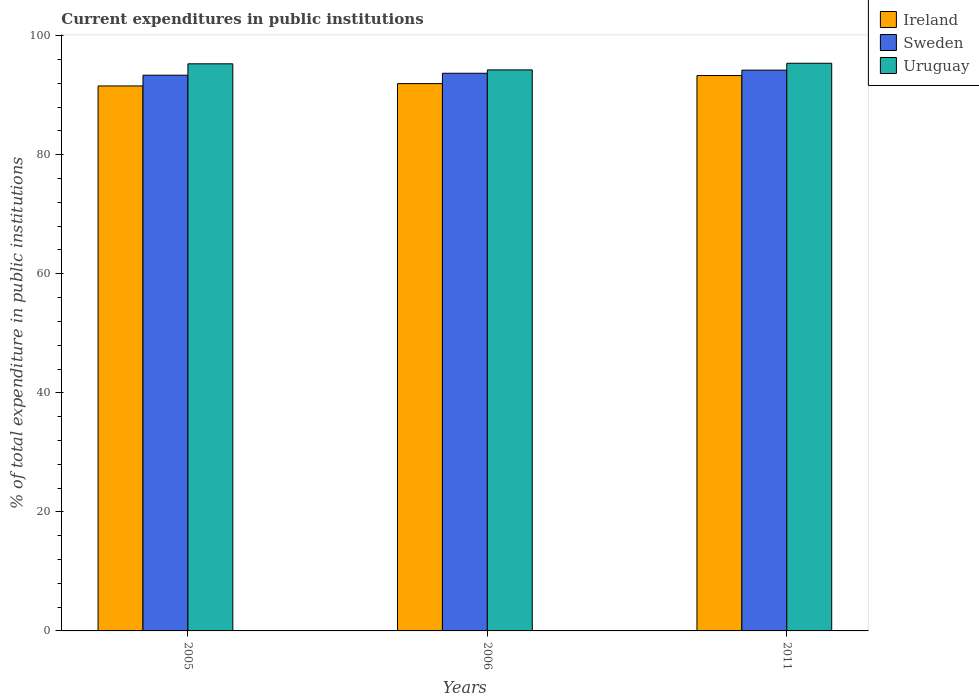How many different coloured bars are there?
Your answer should be compact. 3. How many groups of bars are there?
Make the answer very short. 3. How many bars are there on the 2nd tick from the left?
Make the answer very short. 3. How many bars are there on the 2nd tick from the right?
Offer a terse response. 3. In how many cases, is the number of bars for a given year not equal to the number of legend labels?
Your answer should be very brief. 0. What is the current expenditures in public institutions in Ireland in 2006?
Offer a terse response. 91.95. Across all years, what is the maximum current expenditures in public institutions in Sweden?
Your answer should be compact. 94.22. Across all years, what is the minimum current expenditures in public institutions in Uruguay?
Keep it short and to the point. 94.26. What is the total current expenditures in public institutions in Ireland in the graph?
Provide a short and direct response. 276.82. What is the difference between the current expenditures in public institutions in Uruguay in 2006 and that in 2011?
Offer a very short reply. -1.12. What is the difference between the current expenditures in public institutions in Sweden in 2011 and the current expenditures in public institutions in Uruguay in 2006?
Your response must be concise. -0.04. What is the average current expenditures in public institutions in Ireland per year?
Your answer should be very brief. 92.27. In the year 2011, what is the difference between the current expenditures in public institutions in Sweden and current expenditures in public institutions in Uruguay?
Keep it short and to the point. -1.15. What is the ratio of the current expenditures in public institutions in Uruguay in 2005 to that in 2006?
Your response must be concise. 1.01. What is the difference between the highest and the second highest current expenditures in public institutions in Sweden?
Make the answer very short. 0.52. What is the difference between the highest and the lowest current expenditures in public institutions in Ireland?
Keep it short and to the point. 1.75. What does the 1st bar from the left in 2005 represents?
Your answer should be compact. Ireland. What does the 2nd bar from the right in 2011 represents?
Offer a very short reply. Sweden. How many bars are there?
Offer a terse response. 9. How many years are there in the graph?
Keep it short and to the point. 3. Does the graph contain grids?
Your answer should be very brief. No. Where does the legend appear in the graph?
Offer a terse response. Top right. How many legend labels are there?
Make the answer very short. 3. What is the title of the graph?
Provide a short and direct response. Current expenditures in public institutions. Does "Togo" appear as one of the legend labels in the graph?
Make the answer very short. No. What is the label or title of the X-axis?
Ensure brevity in your answer.  Years. What is the label or title of the Y-axis?
Your response must be concise. % of total expenditure in public institutions. What is the % of total expenditure in public institutions in Ireland in 2005?
Give a very brief answer. 91.56. What is the % of total expenditure in public institutions in Sweden in 2005?
Your response must be concise. 93.37. What is the % of total expenditure in public institutions in Uruguay in 2005?
Your answer should be compact. 95.28. What is the % of total expenditure in public institutions of Ireland in 2006?
Your answer should be compact. 91.95. What is the % of total expenditure in public institutions in Sweden in 2006?
Provide a succinct answer. 93.69. What is the % of total expenditure in public institutions of Uruguay in 2006?
Offer a very short reply. 94.26. What is the % of total expenditure in public institutions of Ireland in 2011?
Make the answer very short. 93.31. What is the % of total expenditure in public institutions of Sweden in 2011?
Provide a succinct answer. 94.22. What is the % of total expenditure in public institutions of Uruguay in 2011?
Your answer should be very brief. 95.37. Across all years, what is the maximum % of total expenditure in public institutions in Ireland?
Provide a short and direct response. 93.31. Across all years, what is the maximum % of total expenditure in public institutions of Sweden?
Keep it short and to the point. 94.22. Across all years, what is the maximum % of total expenditure in public institutions in Uruguay?
Offer a very short reply. 95.37. Across all years, what is the minimum % of total expenditure in public institutions of Ireland?
Offer a terse response. 91.56. Across all years, what is the minimum % of total expenditure in public institutions in Sweden?
Offer a terse response. 93.37. Across all years, what is the minimum % of total expenditure in public institutions in Uruguay?
Your answer should be compact. 94.26. What is the total % of total expenditure in public institutions of Ireland in the graph?
Ensure brevity in your answer.  276.82. What is the total % of total expenditure in public institutions in Sweden in the graph?
Your answer should be very brief. 281.28. What is the total % of total expenditure in public institutions of Uruguay in the graph?
Your response must be concise. 284.91. What is the difference between the % of total expenditure in public institutions of Ireland in 2005 and that in 2006?
Provide a short and direct response. -0.39. What is the difference between the % of total expenditure in public institutions in Sweden in 2005 and that in 2006?
Ensure brevity in your answer.  -0.33. What is the difference between the % of total expenditure in public institutions of Uruguay in 2005 and that in 2006?
Offer a terse response. 1.02. What is the difference between the % of total expenditure in public institutions of Ireland in 2005 and that in 2011?
Keep it short and to the point. -1.75. What is the difference between the % of total expenditure in public institutions of Sweden in 2005 and that in 2011?
Offer a very short reply. -0.85. What is the difference between the % of total expenditure in public institutions in Uruguay in 2005 and that in 2011?
Make the answer very short. -0.1. What is the difference between the % of total expenditure in public institutions of Ireland in 2006 and that in 2011?
Make the answer very short. -1.36. What is the difference between the % of total expenditure in public institutions of Sweden in 2006 and that in 2011?
Offer a very short reply. -0.52. What is the difference between the % of total expenditure in public institutions of Uruguay in 2006 and that in 2011?
Provide a short and direct response. -1.12. What is the difference between the % of total expenditure in public institutions of Ireland in 2005 and the % of total expenditure in public institutions of Sweden in 2006?
Keep it short and to the point. -2.13. What is the difference between the % of total expenditure in public institutions in Ireland in 2005 and the % of total expenditure in public institutions in Uruguay in 2006?
Make the answer very short. -2.7. What is the difference between the % of total expenditure in public institutions of Sweden in 2005 and the % of total expenditure in public institutions of Uruguay in 2006?
Make the answer very short. -0.89. What is the difference between the % of total expenditure in public institutions in Ireland in 2005 and the % of total expenditure in public institutions in Sweden in 2011?
Your answer should be compact. -2.66. What is the difference between the % of total expenditure in public institutions of Ireland in 2005 and the % of total expenditure in public institutions of Uruguay in 2011?
Keep it short and to the point. -3.81. What is the difference between the % of total expenditure in public institutions in Sweden in 2005 and the % of total expenditure in public institutions in Uruguay in 2011?
Offer a terse response. -2.01. What is the difference between the % of total expenditure in public institutions in Ireland in 2006 and the % of total expenditure in public institutions in Sweden in 2011?
Your response must be concise. -2.27. What is the difference between the % of total expenditure in public institutions in Ireland in 2006 and the % of total expenditure in public institutions in Uruguay in 2011?
Your response must be concise. -3.42. What is the difference between the % of total expenditure in public institutions in Sweden in 2006 and the % of total expenditure in public institutions in Uruguay in 2011?
Give a very brief answer. -1.68. What is the average % of total expenditure in public institutions in Ireland per year?
Your response must be concise. 92.27. What is the average % of total expenditure in public institutions in Sweden per year?
Ensure brevity in your answer.  93.76. What is the average % of total expenditure in public institutions in Uruguay per year?
Ensure brevity in your answer.  94.97. In the year 2005, what is the difference between the % of total expenditure in public institutions of Ireland and % of total expenditure in public institutions of Sweden?
Provide a succinct answer. -1.81. In the year 2005, what is the difference between the % of total expenditure in public institutions in Ireland and % of total expenditure in public institutions in Uruguay?
Ensure brevity in your answer.  -3.72. In the year 2005, what is the difference between the % of total expenditure in public institutions in Sweden and % of total expenditure in public institutions in Uruguay?
Offer a terse response. -1.91. In the year 2006, what is the difference between the % of total expenditure in public institutions in Ireland and % of total expenditure in public institutions in Sweden?
Offer a terse response. -1.74. In the year 2006, what is the difference between the % of total expenditure in public institutions in Ireland and % of total expenditure in public institutions in Uruguay?
Make the answer very short. -2.31. In the year 2006, what is the difference between the % of total expenditure in public institutions of Sweden and % of total expenditure in public institutions of Uruguay?
Your answer should be compact. -0.56. In the year 2011, what is the difference between the % of total expenditure in public institutions of Ireland and % of total expenditure in public institutions of Sweden?
Offer a very short reply. -0.91. In the year 2011, what is the difference between the % of total expenditure in public institutions in Ireland and % of total expenditure in public institutions in Uruguay?
Make the answer very short. -2.06. In the year 2011, what is the difference between the % of total expenditure in public institutions in Sweden and % of total expenditure in public institutions in Uruguay?
Provide a short and direct response. -1.15. What is the ratio of the % of total expenditure in public institutions in Ireland in 2005 to that in 2006?
Your answer should be compact. 1. What is the ratio of the % of total expenditure in public institutions of Uruguay in 2005 to that in 2006?
Your answer should be very brief. 1.01. What is the ratio of the % of total expenditure in public institutions in Ireland in 2005 to that in 2011?
Ensure brevity in your answer.  0.98. What is the ratio of the % of total expenditure in public institutions in Ireland in 2006 to that in 2011?
Your response must be concise. 0.99. What is the ratio of the % of total expenditure in public institutions of Sweden in 2006 to that in 2011?
Provide a short and direct response. 0.99. What is the ratio of the % of total expenditure in public institutions in Uruguay in 2006 to that in 2011?
Your response must be concise. 0.99. What is the difference between the highest and the second highest % of total expenditure in public institutions of Ireland?
Your answer should be compact. 1.36. What is the difference between the highest and the second highest % of total expenditure in public institutions of Sweden?
Your response must be concise. 0.52. What is the difference between the highest and the second highest % of total expenditure in public institutions in Uruguay?
Offer a terse response. 0.1. What is the difference between the highest and the lowest % of total expenditure in public institutions of Ireland?
Keep it short and to the point. 1.75. What is the difference between the highest and the lowest % of total expenditure in public institutions in Sweden?
Offer a terse response. 0.85. What is the difference between the highest and the lowest % of total expenditure in public institutions of Uruguay?
Your answer should be compact. 1.12. 